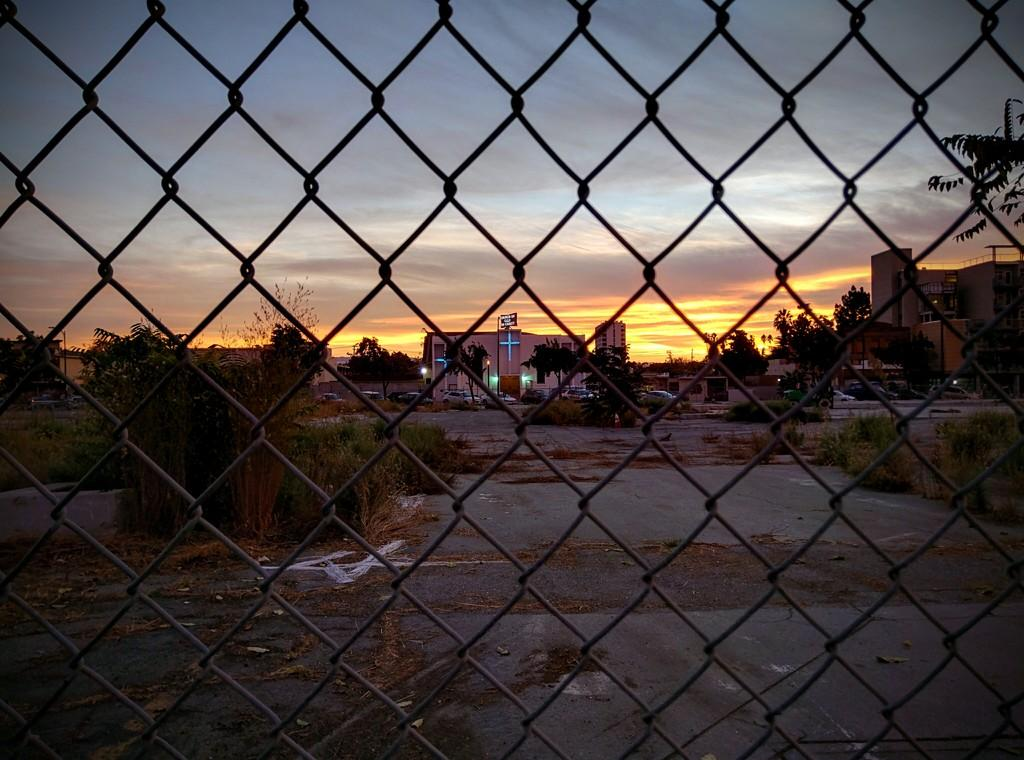What type of structure is visible in the image? There is an iron net in the image. What can be seen in the distance behind the iron net? There are buildings and trees in the background of the image. What is the title of the book that is being read by the person in the image? There is no person or book present in the image; it only features an iron net and background elements. 